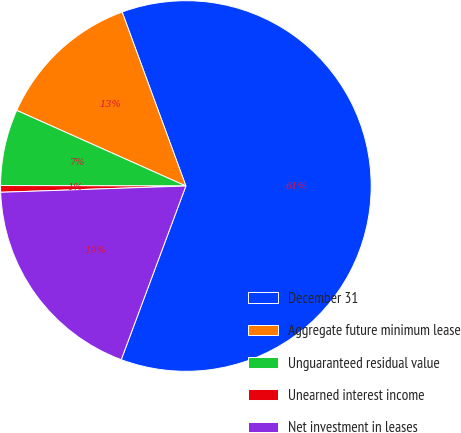Convert chart. <chart><loc_0><loc_0><loc_500><loc_500><pie_chart><fcel>December 31<fcel>Aggregate future minimum lease<fcel>Unguaranteed residual value<fcel>Unearned interest income<fcel>Net investment in leases<nl><fcel>61.27%<fcel>12.72%<fcel>6.65%<fcel>0.58%<fcel>18.79%<nl></chart> 